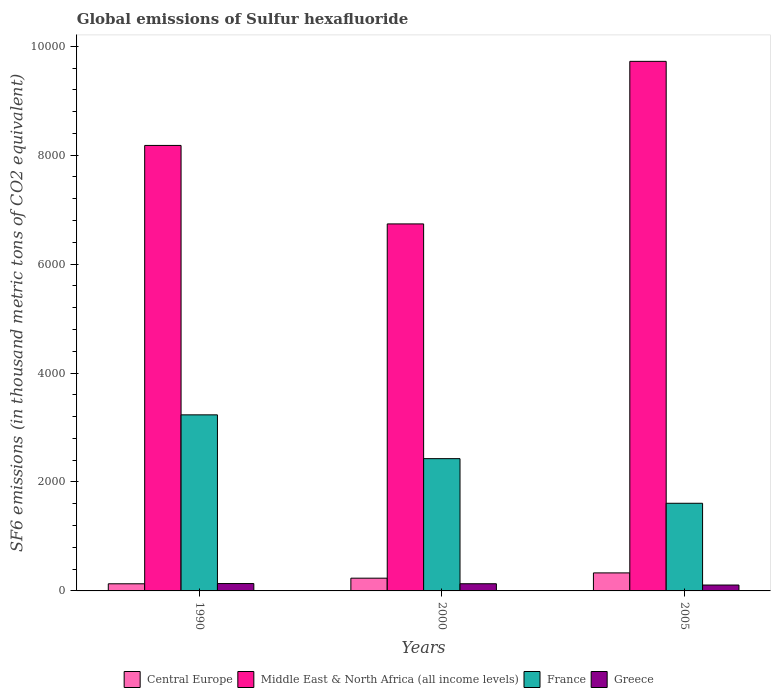How many different coloured bars are there?
Make the answer very short. 4. How many groups of bars are there?
Give a very brief answer. 3. Are the number of bars on each tick of the X-axis equal?
Offer a terse response. Yes. How many bars are there on the 1st tick from the left?
Ensure brevity in your answer.  4. What is the label of the 1st group of bars from the left?
Your answer should be very brief. 1990. What is the global emissions of Sulfur hexafluoride in Central Europe in 2000?
Your answer should be compact. 234. Across all years, what is the maximum global emissions of Sulfur hexafluoride in Middle East & North Africa (all income levels)?
Provide a succinct answer. 9723.31. Across all years, what is the minimum global emissions of Sulfur hexafluoride in Greece?
Your answer should be compact. 108.1. What is the total global emissions of Sulfur hexafluoride in Central Europe in the graph?
Make the answer very short. 695.99. What is the difference between the global emissions of Sulfur hexafluoride in Central Europe in 2000 and that in 2005?
Make the answer very short. -96.99. What is the difference between the global emissions of Sulfur hexafluoride in Middle East & North Africa (all income levels) in 2000 and the global emissions of Sulfur hexafluoride in Central Europe in 2005?
Your answer should be compact. 6407.51. What is the average global emissions of Sulfur hexafluoride in Greece per year?
Give a very brief answer. 125.1. In the year 2000, what is the difference between the global emissions of Sulfur hexafluoride in Central Europe and global emissions of Sulfur hexafluoride in Greece?
Provide a short and direct response. 102.2. In how many years, is the global emissions of Sulfur hexafluoride in Central Europe greater than 400 thousand metric tons?
Offer a terse response. 0. What is the ratio of the global emissions of Sulfur hexafluoride in Central Europe in 1990 to that in 2000?
Give a very brief answer. 0.56. What is the difference between the highest and the second highest global emissions of Sulfur hexafluoride in Greece?
Give a very brief answer. 3.6. What is the difference between the highest and the lowest global emissions of Sulfur hexafluoride in Middle East & North Africa (all income levels)?
Make the answer very short. 2984.81. Is the sum of the global emissions of Sulfur hexafluoride in Central Europe in 2000 and 2005 greater than the maximum global emissions of Sulfur hexafluoride in Greece across all years?
Provide a succinct answer. Yes. Is it the case that in every year, the sum of the global emissions of Sulfur hexafluoride in Middle East & North Africa (all income levels) and global emissions of Sulfur hexafluoride in France is greater than the sum of global emissions of Sulfur hexafluoride in Central Europe and global emissions of Sulfur hexafluoride in Greece?
Provide a succinct answer. Yes. How many bars are there?
Your response must be concise. 12. Are all the bars in the graph horizontal?
Give a very brief answer. No. Are the values on the major ticks of Y-axis written in scientific E-notation?
Offer a very short reply. No. Does the graph contain any zero values?
Give a very brief answer. No. Does the graph contain grids?
Provide a short and direct response. No. Where does the legend appear in the graph?
Give a very brief answer. Bottom center. How are the legend labels stacked?
Your answer should be very brief. Horizontal. What is the title of the graph?
Your response must be concise. Global emissions of Sulfur hexafluoride. What is the label or title of the X-axis?
Your answer should be very brief. Years. What is the label or title of the Y-axis?
Provide a succinct answer. SF6 emissions (in thousand metric tons of CO2 equivalent). What is the SF6 emissions (in thousand metric tons of CO2 equivalent) of Central Europe in 1990?
Ensure brevity in your answer.  131. What is the SF6 emissions (in thousand metric tons of CO2 equivalent) of Middle East & North Africa (all income levels) in 1990?
Keep it short and to the point. 8179.7. What is the SF6 emissions (in thousand metric tons of CO2 equivalent) of France in 1990?
Your answer should be compact. 3232.8. What is the SF6 emissions (in thousand metric tons of CO2 equivalent) of Greece in 1990?
Offer a terse response. 135.4. What is the SF6 emissions (in thousand metric tons of CO2 equivalent) in Central Europe in 2000?
Your response must be concise. 234. What is the SF6 emissions (in thousand metric tons of CO2 equivalent) in Middle East & North Africa (all income levels) in 2000?
Your answer should be compact. 6738.5. What is the SF6 emissions (in thousand metric tons of CO2 equivalent) of France in 2000?
Make the answer very short. 2428.5. What is the SF6 emissions (in thousand metric tons of CO2 equivalent) in Greece in 2000?
Your answer should be compact. 131.8. What is the SF6 emissions (in thousand metric tons of CO2 equivalent) of Central Europe in 2005?
Provide a succinct answer. 330.99. What is the SF6 emissions (in thousand metric tons of CO2 equivalent) in Middle East & North Africa (all income levels) in 2005?
Give a very brief answer. 9723.31. What is the SF6 emissions (in thousand metric tons of CO2 equivalent) in France in 2005?
Make the answer very short. 1609.4. What is the SF6 emissions (in thousand metric tons of CO2 equivalent) in Greece in 2005?
Your answer should be compact. 108.1. Across all years, what is the maximum SF6 emissions (in thousand metric tons of CO2 equivalent) in Central Europe?
Provide a short and direct response. 330.99. Across all years, what is the maximum SF6 emissions (in thousand metric tons of CO2 equivalent) of Middle East & North Africa (all income levels)?
Your answer should be compact. 9723.31. Across all years, what is the maximum SF6 emissions (in thousand metric tons of CO2 equivalent) in France?
Provide a succinct answer. 3232.8. Across all years, what is the maximum SF6 emissions (in thousand metric tons of CO2 equivalent) in Greece?
Make the answer very short. 135.4. Across all years, what is the minimum SF6 emissions (in thousand metric tons of CO2 equivalent) in Central Europe?
Give a very brief answer. 131. Across all years, what is the minimum SF6 emissions (in thousand metric tons of CO2 equivalent) of Middle East & North Africa (all income levels)?
Ensure brevity in your answer.  6738.5. Across all years, what is the minimum SF6 emissions (in thousand metric tons of CO2 equivalent) of France?
Keep it short and to the point. 1609.4. Across all years, what is the minimum SF6 emissions (in thousand metric tons of CO2 equivalent) in Greece?
Your answer should be compact. 108.1. What is the total SF6 emissions (in thousand metric tons of CO2 equivalent) in Central Europe in the graph?
Provide a succinct answer. 695.99. What is the total SF6 emissions (in thousand metric tons of CO2 equivalent) of Middle East & North Africa (all income levels) in the graph?
Keep it short and to the point. 2.46e+04. What is the total SF6 emissions (in thousand metric tons of CO2 equivalent) in France in the graph?
Your answer should be compact. 7270.7. What is the total SF6 emissions (in thousand metric tons of CO2 equivalent) of Greece in the graph?
Your response must be concise. 375.3. What is the difference between the SF6 emissions (in thousand metric tons of CO2 equivalent) in Central Europe in 1990 and that in 2000?
Offer a terse response. -103. What is the difference between the SF6 emissions (in thousand metric tons of CO2 equivalent) in Middle East & North Africa (all income levels) in 1990 and that in 2000?
Provide a succinct answer. 1441.2. What is the difference between the SF6 emissions (in thousand metric tons of CO2 equivalent) of France in 1990 and that in 2000?
Provide a succinct answer. 804.3. What is the difference between the SF6 emissions (in thousand metric tons of CO2 equivalent) of Greece in 1990 and that in 2000?
Your response must be concise. 3.6. What is the difference between the SF6 emissions (in thousand metric tons of CO2 equivalent) in Central Europe in 1990 and that in 2005?
Ensure brevity in your answer.  -199.99. What is the difference between the SF6 emissions (in thousand metric tons of CO2 equivalent) of Middle East & North Africa (all income levels) in 1990 and that in 2005?
Keep it short and to the point. -1543.61. What is the difference between the SF6 emissions (in thousand metric tons of CO2 equivalent) in France in 1990 and that in 2005?
Offer a very short reply. 1623.4. What is the difference between the SF6 emissions (in thousand metric tons of CO2 equivalent) in Greece in 1990 and that in 2005?
Your answer should be compact. 27.3. What is the difference between the SF6 emissions (in thousand metric tons of CO2 equivalent) of Central Europe in 2000 and that in 2005?
Offer a terse response. -96.99. What is the difference between the SF6 emissions (in thousand metric tons of CO2 equivalent) of Middle East & North Africa (all income levels) in 2000 and that in 2005?
Provide a succinct answer. -2984.81. What is the difference between the SF6 emissions (in thousand metric tons of CO2 equivalent) in France in 2000 and that in 2005?
Ensure brevity in your answer.  819.1. What is the difference between the SF6 emissions (in thousand metric tons of CO2 equivalent) in Greece in 2000 and that in 2005?
Your response must be concise. 23.7. What is the difference between the SF6 emissions (in thousand metric tons of CO2 equivalent) in Central Europe in 1990 and the SF6 emissions (in thousand metric tons of CO2 equivalent) in Middle East & North Africa (all income levels) in 2000?
Ensure brevity in your answer.  -6607.5. What is the difference between the SF6 emissions (in thousand metric tons of CO2 equivalent) of Central Europe in 1990 and the SF6 emissions (in thousand metric tons of CO2 equivalent) of France in 2000?
Your response must be concise. -2297.5. What is the difference between the SF6 emissions (in thousand metric tons of CO2 equivalent) in Middle East & North Africa (all income levels) in 1990 and the SF6 emissions (in thousand metric tons of CO2 equivalent) in France in 2000?
Make the answer very short. 5751.2. What is the difference between the SF6 emissions (in thousand metric tons of CO2 equivalent) of Middle East & North Africa (all income levels) in 1990 and the SF6 emissions (in thousand metric tons of CO2 equivalent) of Greece in 2000?
Provide a short and direct response. 8047.9. What is the difference between the SF6 emissions (in thousand metric tons of CO2 equivalent) of France in 1990 and the SF6 emissions (in thousand metric tons of CO2 equivalent) of Greece in 2000?
Provide a short and direct response. 3101. What is the difference between the SF6 emissions (in thousand metric tons of CO2 equivalent) in Central Europe in 1990 and the SF6 emissions (in thousand metric tons of CO2 equivalent) in Middle East & North Africa (all income levels) in 2005?
Your answer should be compact. -9592.31. What is the difference between the SF6 emissions (in thousand metric tons of CO2 equivalent) of Central Europe in 1990 and the SF6 emissions (in thousand metric tons of CO2 equivalent) of France in 2005?
Offer a very short reply. -1478.4. What is the difference between the SF6 emissions (in thousand metric tons of CO2 equivalent) of Central Europe in 1990 and the SF6 emissions (in thousand metric tons of CO2 equivalent) of Greece in 2005?
Make the answer very short. 22.9. What is the difference between the SF6 emissions (in thousand metric tons of CO2 equivalent) of Middle East & North Africa (all income levels) in 1990 and the SF6 emissions (in thousand metric tons of CO2 equivalent) of France in 2005?
Your answer should be very brief. 6570.3. What is the difference between the SF6 emissions (in thousand metric tons of CO2 equivalent) of Middle East & North Africa (all income levels) in 1990 and the SF6 emissions (in thousand metric tons of CO2 equivalent) of Greece in 2005?
Keep it short and to the point. 8071.6. What is the difference between the SF6 emissions (in thousand metric tons of CO2 equivalent) in France in 1990 and the SF6 emissions (in thousand metric tons of CO2 equivalent) in Greece in 2005?
Give a very brief answer. 3124.7. What is the difference between the SF6 emissions (in thousand metric tons of CO2 equivalent) of Central Europe in 2000 and the SF6 emissions (in thousand metric tons of CO2 equivalent) of Middle East & North Africa (all income levels) in 2005?
Keep it short and to the point. -9489.31. What is the difference between the SF6 emissions (in thousand metric tons of CO2 equivalent) in Central Europe in 2000 and the SF6 emissions (in thousand metric tons of CO2 equivalent) in France in 2005?
Give a very brief answer. -1375.4. What is the difference between the SF6 emissions (in thousand metric tons of CO2 equivalent) in Central Europe in 2000 and the SF6 emissions (in thousand metric tons of CO2 equivalent) in Greece in 2005?
Ensure brevity in your answer.  125.9. What is the difference between the SF6 emissions (in thousand metric tons of CO2 equivalent) in Middle East & North Africa (all income levels) in 2000 and the SF6 emissions (in thousand metric tons of CO2 equivalent) in France in 2005?
Your answer should be very brief. 5129.1. What is the difference between the SF6 emissions (in thousand metric tons of CO2 equivalent) of Middle East & North Africa (all income levels) in 2000 and the SF6 emissions (in thousand metric tons of CO2 equivalent) of Greece in 2005?
Your answer should be compact. 6630.4. What is the difference between the SF6 emissions (in thousand metric tons of CO2 equivalent) in France in 2000 and the SF6 emissions (in thousand metric tons of CO2 equivalent) in Greece in 2005?
Provide a succinct answer. 2320.4. What is the average SF6 emissions (in thousand metric tons of CO2 equivalent) in Central Europe per year?
Ensure brevity in your answer.  232. What is the average SF6 emissions (in thousand metric tons of CO2 equivalent) in Middle East & North Africa (all income levels) per year?
Your response must be concise. 8213.84. What is the average SF6 emissions (in thousand metric tons of CO2 equivalent) in France per year?
Offer a very short reply. 2423.57. What is the average SF6 emissions (in thousand metric tons of CO2 equivalent) in Greece per year?
Your answer should be very brief. 125.1. In the year 1990, what is the difference between the SF6 emissions (in thousand metric tons of CO2 equivalent) in Central Europe and SF6 emissions (in thousand metric tons of CO2 equivalent) in Middle East & North Africa (all income levels)?
Give a very brief answer. -8048.7. In the year 1990, what is the difference between the SF6 emissions (in thousand metric tons of CO2 equivalent) in Central Europe and SF6 emissions (in thousand metric tons of CO2 equivalent) in France?
Give a very brief answer. -3101.8. In the year 1990, what is the difference between the SF6 emissions (in thousand metric tons of CO2 equivalent) in Middle East & North Africa (all income levels) and SF6 emissions (in thousand metric tons of CO2 equivalent) in France?
Your response must be concise. 4946.9. In the year 1990, what is the difference between the SF6 emissions (in thousand metric tons of CO2 equivalent) in Middle East & North Africa (all income levels) and SF6 emissions (in thousand metric tons of CO2 equivalent) in Greece?
Your answer should be very brief. 8044.3. In the year 1990, what is the difference between the SF6 emissions (in thousand metric tons of CO2 equivalent) in France and SF6 emissions (in thousand metric tons of CO2 equivalent) in Greece?
Keep it short and to the point. 3097.4. In the year 2000, what is the difference between the SF6 emissions (in thousand metric tons of CO2 equivalent) in Central Europe and SF6 emissions (in thousand metric tons of CO2 equivalent) in Middle East & North Africa (all income levels)?
Make the answer very short. -6504.5. In the year 2000, what is the difference between the SF6 emissions (in thousand metric tons of CO2 equivalent) in Central Europe and SF6 emissions (in thousand metric tons of CO2 equivalent) in France?
Your answer should be compact. -2194.5. In the year 2000, what is the difference between the SF6 emissions (in thousand metric tons of CO2 equivalent) of Central Europe and SF6 emissions (in thousand metric tons of CO2 equivalent) of Greece?
Make the answer very short. 102.2. In the year 2000, what is the difference between the SF6 emissions (in thousand metric tons of CO2 equivalent) of Middle East & North Africa (all income levels) and SF6 emissions (in thousand metric tons of CO2 equivalent) of France?
Your response must be concise. 4310. In the year 2000, what is the difference between the SF6 emissions (in thousand metric tons of CO2 equivalent) of Middle East & North Africa (all income levels) and SF6 emissions (in thousand metric tons of CO2 equivalent) of Greece?
Offer a very short reply. 6606.7. In the year 2000, what is the difference between the SF6 emissions (in thousand metric tons of CO2 equivalent) in France and SF6 emissions (in thousand metric tons of CO2 equivalent) in Greece?
Your response must be concise. 2296.7. In the year 2005, what is the difference between the SF6 emissions (in thousand metric tons of CO2 equivalent) in Central Europe and SF6 emissions (in thousand metric tons of CO2 equivalent) in Middle East & North Africa (all income levels)?
Ensure brevity in your answer.  -9392.32. In the year 2005, what is the difference between the SF6 emissions (in thousand metric tons of CO2 equivalent) in Central Europe and SF6 emissions (in thousand metric tons of CO2 equivalent) in France?
Provide a succinct answer. -1278.41. In the year 2005, what is the difference between the SF6 emissions (in thousand metric tons of CO2 equivalent) in Central Europe and SF6 emissions (in thousand metric tons of CO2 equivalent) in Greece?
Your response must be concise. 222.89. In the year 2005, what is the difference between the SF6 emissions (in thousand metric tons of CO2 equivalent) in Middle East & North Africa (all income levels) and SF6 emissions (in thousand metric tons of CO2 equivalent) in France?
Your answer should be very brief. 8113.91. In the year 2005, what is the difference between the SF6 emissions (in thousand metric tons of CO2 equivalent) in Middle East & North Africa (all income levels) and SF6 emissions (in thousand metric tons of CO2 equivalent) in Greece?
Offer a terse response. 9615.21. In the year 2005, what is the difference between the SF6 emissions (in thousand metric tons of CO2 equivalent) in France and SF6 emissions (in thousand metric tons of CO2 equivalent) in Greece?
Give a very brief answer. 1501.3. What is the ratio of the SF6 emissions (in thousand metric tons of CO2 equivalent) in Central Europe in 1990 to that in 2000?
Offer a very short reply. 0.56. What is the ratio of the SF6 emissions (in thousand metric tons of CO2 equivalent) of Middle East & North Africa (all income levels) in 1990 to that in 2000?
Your response must be concise. 1.21. What is the ratio of the SF6 emissions (in thousand metric tons of CO2 equivalent) in France in 1990 to that in 2000?
Give a very brief answer. 1.33. What is the ratio of the SF6 emissions (in thousand metric tons of CO2 equivalent) in Greece in 1990 to that in 2000?
Your answer should be compact. 1.03. What is the ratio of the SF6 emissions (in thousand metric tons of CO2 equivalent) of Central Europe in 1990 to that in 2005?
Make the answer very short. 0.4. What is the ratio of the SF6 emissions (in thousand metric tons of CO2 equivalent) in Middle East & North Africa (all income levels) in 1990 to that in 2005?
Ensure brevity in your answer.  0.84. What is the ratio of the SF6 emissions (in thousand metric tons of CO2 equivalent) of France in 1990 to that in 2005?
Provide a succinct answer. 2.01. What is the ratio of the SF6 emissions (in thousand metric tons of CO2 equivalent) in Greece in 1990 to that in 2005?
Offer a very short reply. 1.25. What is the ratio of the SF6 emissions (in thousand metric tons of CO2 equivalent) in Central Europe in 2000 to that in 2005?
Provide a short and direct response. 0.71. What is the ratio of the SF6 emissions (in thousand metric tons of CO2 equivalent) in Middle East & North Africa (all income levels) in 2000 to that in 2005?
Keep it short and to the point. 0.69. What is the ratio of the SF6 emissions (in thousand metric tons of CO2 equivalent) of France in 2000 to that in 2005?
Offer a very short reply. 1.51. What is the ratio of the SF6 emissions (in thousand metric tons of CO2 equivalent) in Greece in 2000 to that in 2005?
Offer a very short reply. 1.22. What is the difference between the highest and the second highest SF6 emissions (in thousand metric tons of CO2 equivalent) of Central Europe?
Keep it short and to the point. 96.99. What is the difference between the highest and the second highest SF6 emissions (in thousand metric tons of CO2 equivalent) of Middle East & North Africa (all income levels)?
Give a very brief answer. 1543.61. What is the difference between the highest and the second highest SF6 emissions (in thousand metric tons of CO2 equivalent) in France?
Your answer should be very brief. 804.3. What is the difference between the highest and the second highest SF6 emissions (in thousand metric tons of CO2 equivalent) of Greece?
Ensure brevity in your answer.  3.6. What is the difference between the highest and the lowest SF6 emissions (in thousand metric tons of CO2 equivalent) in Central Europe?
Offer a terse response. 199.99. What is the difference between the highest and the lowest SF6 emissions (in thousand metric tons of CO2 equivalent) in Middle East & North Africa (all income levels)?
Make the answer very short. 2984.81. What is the difference between the highest and the lowest SF6 emissions (in thousand metric tons of CO2 equivalent) of France?
Ensure brevity in your answer.  1623.4. What is the difference between the highest and the lowest SF6 emissions (in thousand metric tons of CO2 equivalent) of Greece?
Your response must be concise. 27.3. 